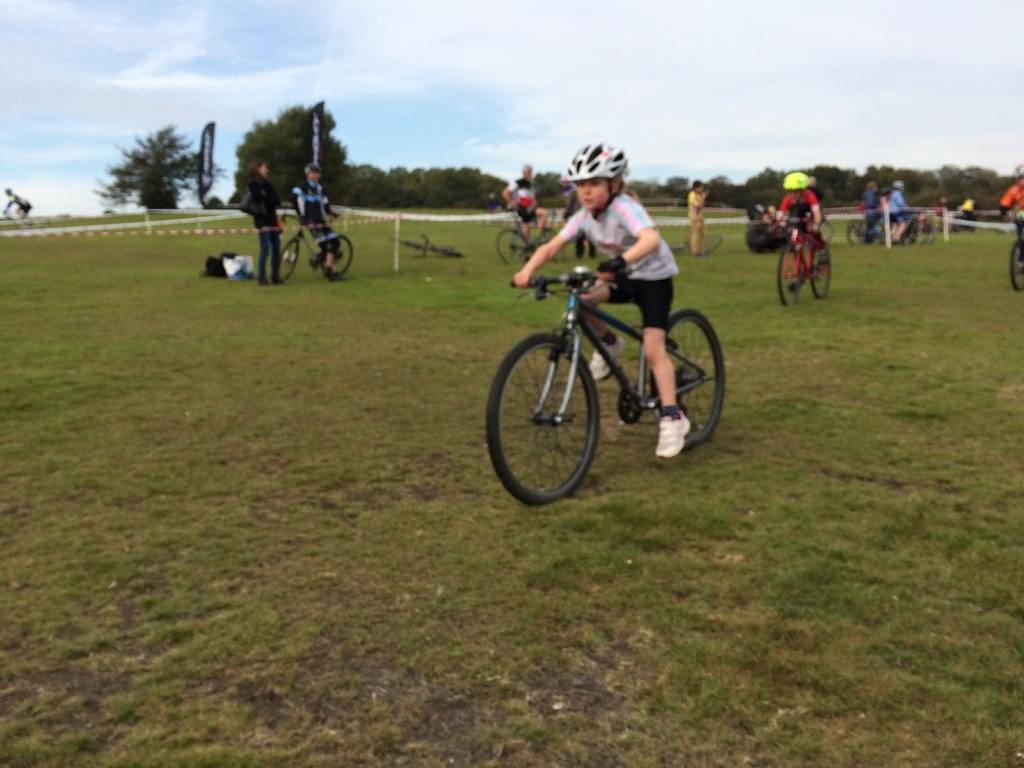What is the primary feature of the land in the image? The land is covered with grass. What are the children doing in the image? The children are riding bicycles. Can you describe the background of the image? In the background, there are bicycles, people, trees, and a hoarding. What is the condition of the sky in the image? The sky is cloudy in the image. What type of salt is being used to create patterns on the grass in the image? There is no salt present in the image, and no patterns are being created on the grass. 